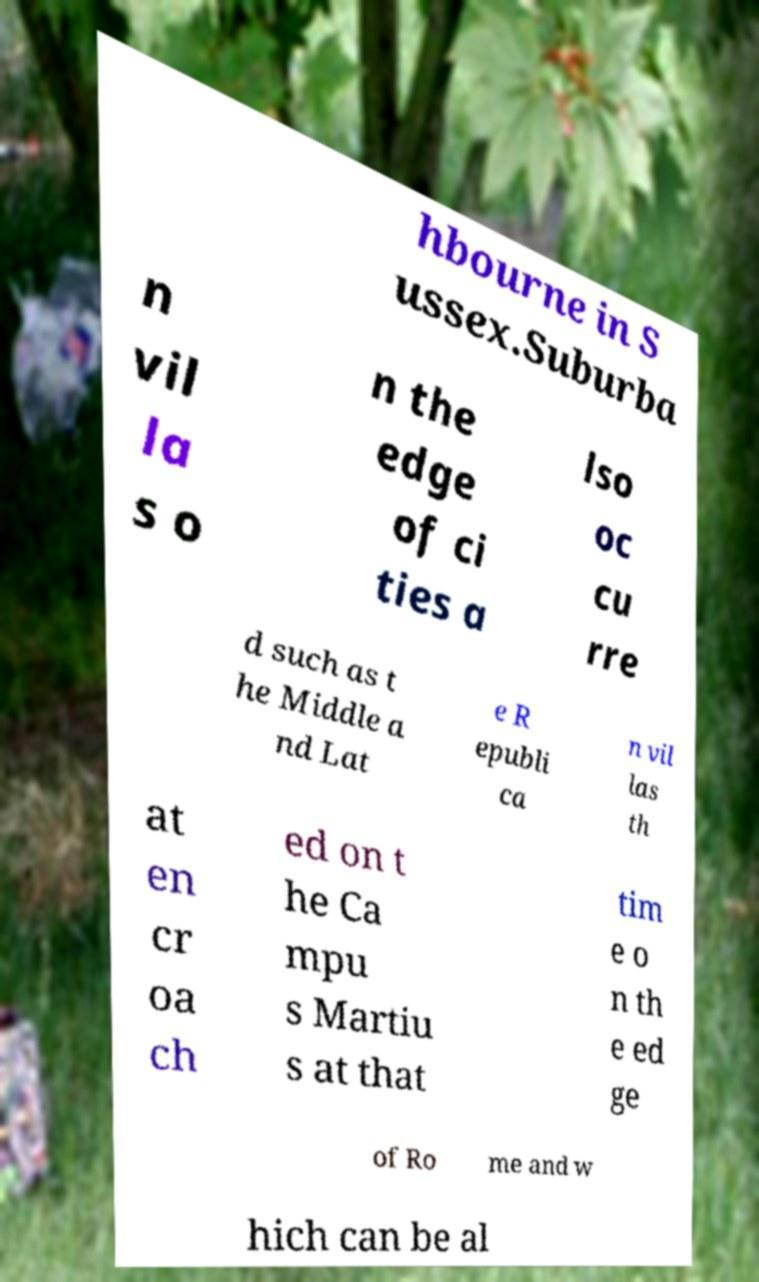Can you read and provide the text displayed in the image?This photo seems to have some interesting text. Can you extract and type it out for me? hbourne in S ussex.Suburba n vil la s o n the edge of ci ties a lso oc cu rre d such as t he Middle a nd Lat e R epubli ca n vil las th at en cr oa ch ed on t he Ca mpu s Martiu s at that tim e o n th e ed ge of Ro me and w hich can be al 